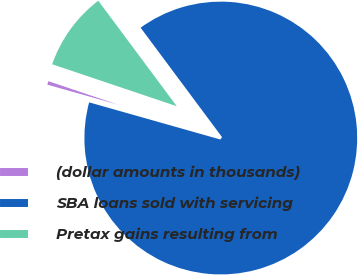<chart> <loc_0><loc_0><loc_500><loc_500><pie_chart><fcel>(dollar amounts in thousands)<fcel>SBA loans sold with servicing<fcel>Pretax gains resulting from<nl><fcel>0.78%<fcel>89.57%<fcel>9.65%<nl></chart> 